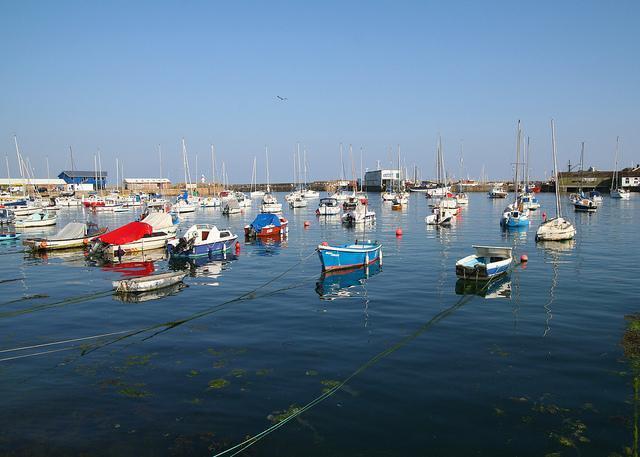How many birds are flying?
Give a very brief answer. 1. How many boats are in the picture?
Give a very brief answer. 2. 